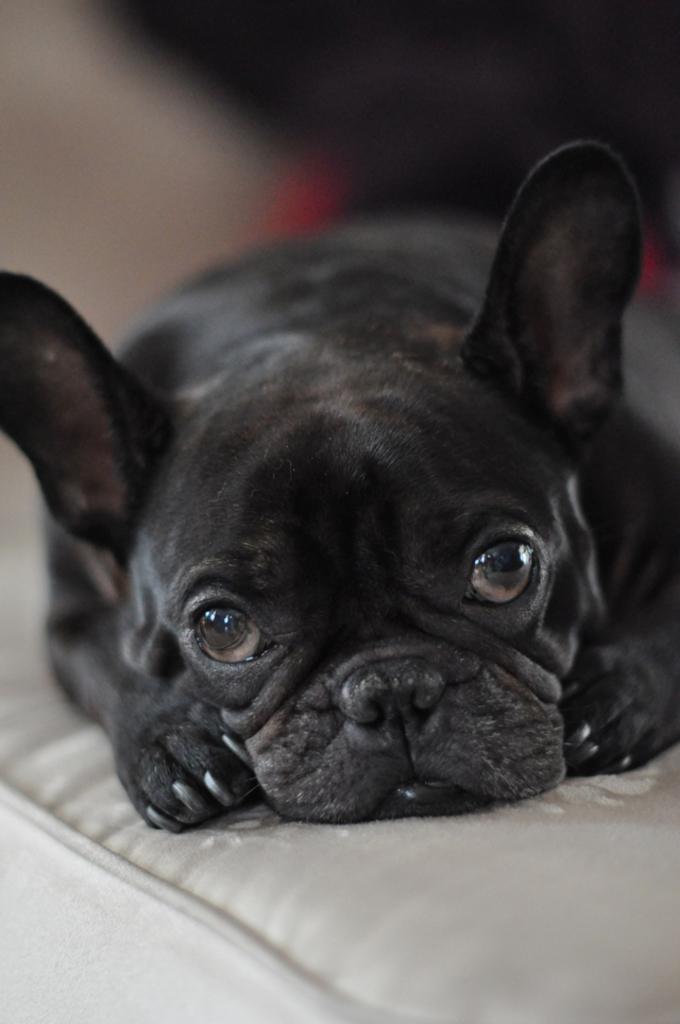In one or two sentences, can you explain what this image depicts? We can see black dog on the surface. In the background it is blur. 